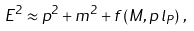<formula> <loc_0><loc_0><loc_500><loc_500>E ^ { 2 } \approx p ^ { 2 } + m ^ { 2 } + f \left ( M , p \, l _ { P } \right ) \, ,</formula> 